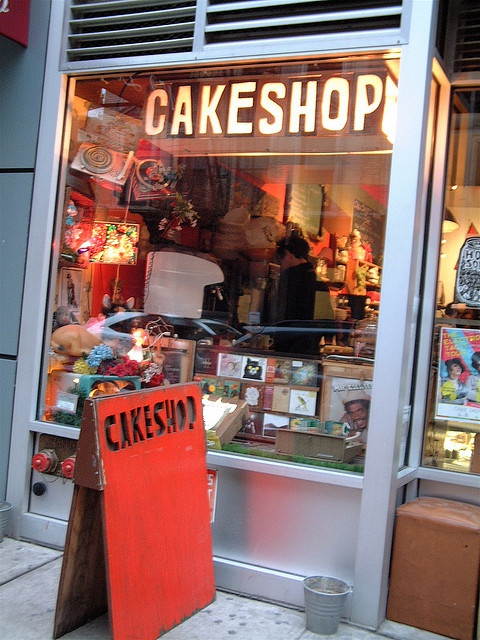Describe the objects in this image and their specific colors. I can see people in gray, black, maroon, and brown tones in this image. 